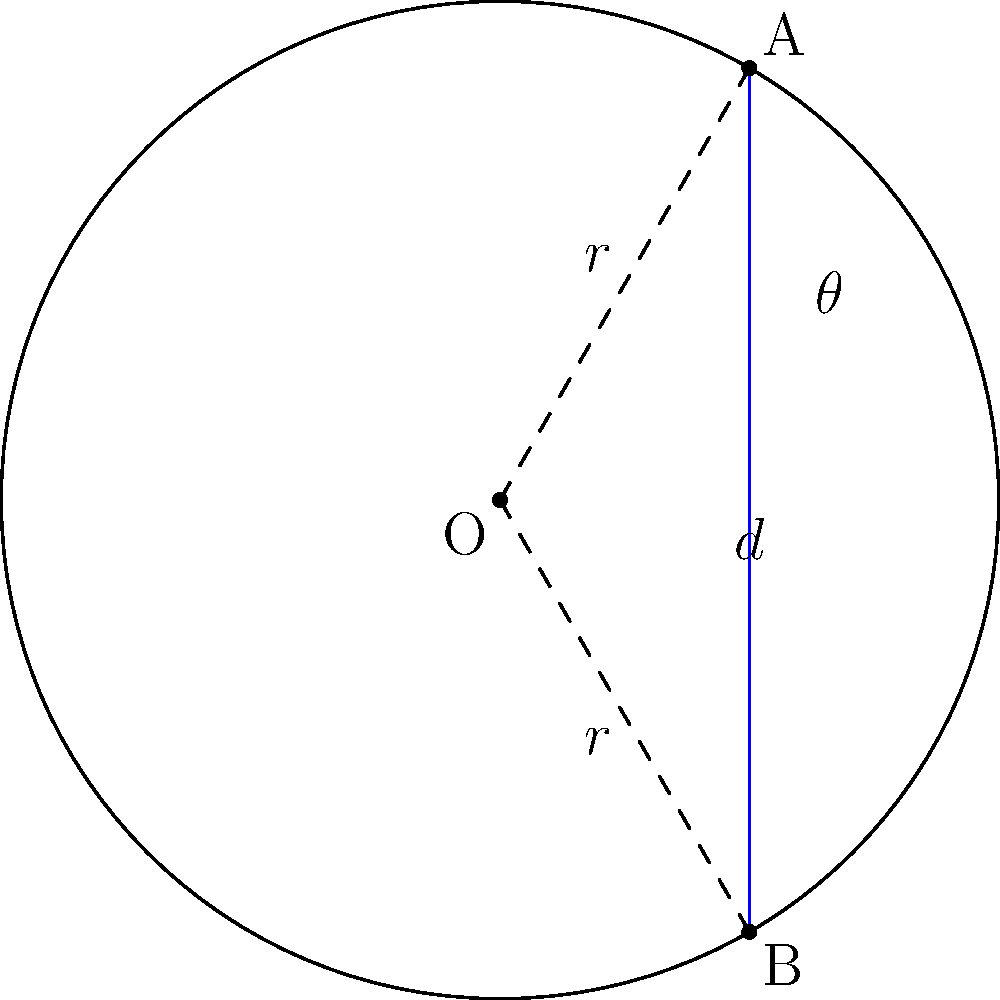In a circle with radius $r$, a chord $AB$ is drawn such that it subtends an angle $\theta$ at the center O. If the length of the chord is $d$, derive an expression for $d$ in terms of $r$ and $\theta$. How does this relationship demonstrate the interplay between circular geometry and trigonometry in materials science applications? Let's approach this step-by-step:

1) In the circle, we have a triangle OAB with the chord AB as its base.

2) The radius OA bisects the angle $\theta$ at the center, creating two right triangles.

3) In one of these right triangles:
   - The hypotenuse is the radius $r$
   - Half of the chord (d/2) is opposite to half of the central angle ($\theta/2$)

4) Using the sine function in this right triangle:

   $$\sin(\theta/2) = \frac{d/2}{r}$$

5) Rearranging this equation:

   $$d/2 = r \sin(\theta/2)$$

6) Multiplying both sides by 2:

   $$d = 2r \sin(\theta/2)$$

This relationship is crucial in materials science, particularly in crystallography and diffraction studies. For instance:

- In X-ray diffraction, Bragg's law uses this principle to determine interplanar spacing in crystal structures.
- In electron microscopy, understanding this relationship helps in interpreting diffraction patterns and analyzing crystal orientations.
- In materials characterization techniques like Small Angle X-ray Scattering (SAXS), this relationship is fundamental in analyzing particle sizes and distributions.

The interplay between circular geometry and trigonometry demonstrated here forms the basis for many quantitative analyses in materials science, bridging the gap between observed patterns and underlying material structures.
Answer: $d = 2r \sin(\theta/2)$ 